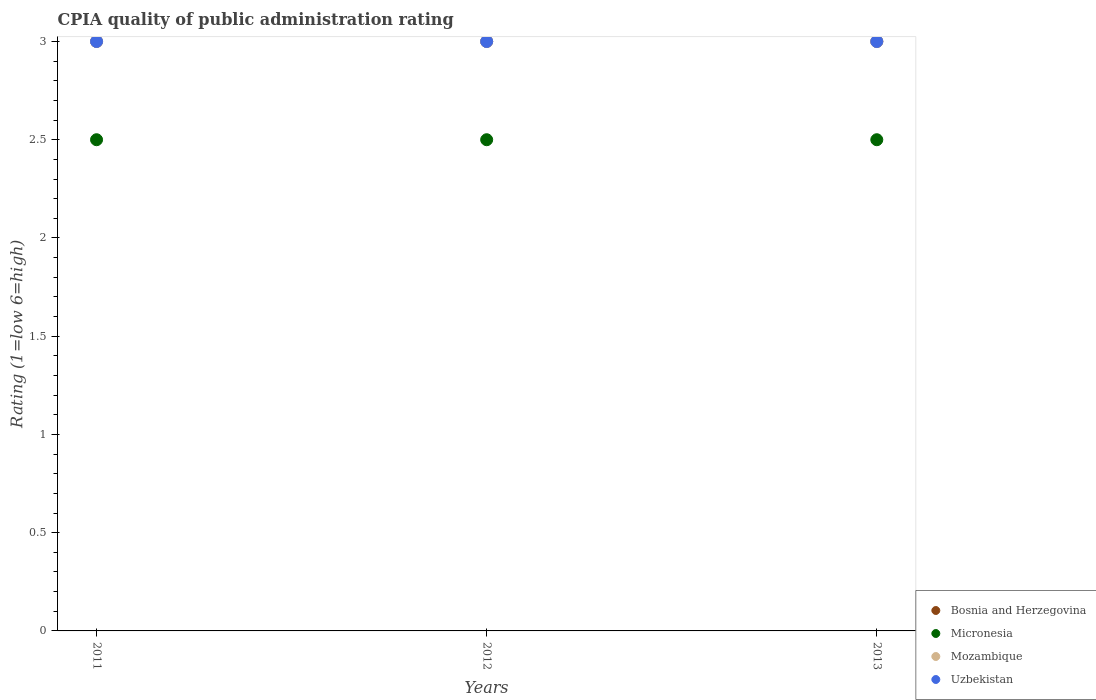How many different coloured dotlines are there?
Your answer should be compact. 4. What is the CPIA rating in Uzbekistan in 2013?
Offer a very short reply. 3. Across all years, what is the minimum CPIA rating in Bosnia and Herzegovina?
Ensure brevity in your answer.  3. In which year was the CPIA rating in Mozambique minimum?
Offer a very short reply. 2011. What is the total CPIA rating in Micronesia in the graph?
Provide a succinct answer. 7.5. What is the difference between the CPIA rating in Uzbekistan in 2012 and that in 2013?
Make the answer very short. 0. What is the ratio of the CPIA rating in Uzbekistan in 2011 to that in 2013?
Provide a short and direct response. 1. Is the CPIA rating in Micronesia in 2011 less than that in 2013?
Make the answer very short. No. Is the difference between the CPIA rating in Bosnia and Herzegovina in 2011 and 2012 greater than the difference between the CPIA rating in Uzbekistan in 2011 and 2012?
Your answer should be very brief. No. What is the difference between the highest and the lowest CPIA rating in Mozambique?
Offer a terse response. 0. In how many years, is the CPIA rating in Uzbekistan greater than the average CPIA rating in Uzbekistan taken over all years?
Make the answer very short. 0. Is it the case that in every year, the sum of the CPIA rating in Mozambique and CPIA rating in Uzbekistan  is greater than the sum of CPIA rating in Micronesia and CPIA rating in Bosnia and Herzegovina?
Your response must be concise. No. Is it the case that in every year, the sum of the CPIA rating in Micronesia and CPIA rating in Bosnia and Herzegovina  is greater than the CPIA rating in Mozambique?
Offer a very short reply. Yes. Are the values on the major ticks of Y-axis written in scientific E-notation?
Your answer should be very brief. No. Where does the legend appear in the graph?
Offer a very short reply. Bottom right. What is the title of the graph?
Your answer should be compact. CPIA quality of public administration rating. Does "Ukraine" appear as one of the legend labels in the graph?
Ensure brevity in your answer.  No. What is the label or title of the Y-axis?
Offer a terse response. Rating (1=low 6=high). What is the Rating (1=low 6=high) of Micronesia in 2011?
Your response must be concise. 2.5. What is the Rating (1=low 6=high) in Bosnia and Herzegovina in 2012?
Make the answer very short. 3. What is the Rating (1=low 6=high) of Micronesia in 2012?
Provide a short and direct response. 2.5. What is the Rating (1=low 6=high) in Uzbekistan in 2012?
Provide a succinct answer. 3. What is the Rating (1=low 6=high) of Micronesia in 2013?
Your answer should be very brief. 2.5. What is the Rating (1=low 6=high) in Uzbekistan in 2013?
Provide a short and direct response. 3. Across all years, what is the maximum Rating (1=low 6=high) in Bosnia and Herzegovina?
Offer a terse response. 3. Across all years, what is the maximum Rating (1=low 6=high) of Micronesia?
Offer a terse response. 2.5. Across all years, what is the maximum Rating (1=low 6=high) of Uzbekistan?
Your response must be concise. 3. Across all years, what is the minimum Rating (1=low 6=high) in Bosnia and Herzegovina?
Your response must be concise. 3. Across all years, what is the minimum Rating (1=low 6=high) of Mozambique?
Provide a short and direct response. 3. What is the total Rating (1=low 6=high) in Micronesia in the graph?
Provide a short and direct response. 7.5. What is the total Rating (1=low 6=high) of Uzbekistan in the graph?
Give a very brief answer. 9. What is the difference between the Rating (1=low 6=high) in Micronesia in 2011 and that in 2012?
Ensure brevity in your answer.  0. What is the difference between the Rating (1=low 6=high) in Mozambique in 2011 and that in 2013?
Offer a terse response. 0. What is the difference between the Rating (1=low 6=high) in Bosnia and Herzegovina in 2012 and that in 2013?
Your answer should be compact. 0. What is the difference between the Rating (1=low 6=high) of Micronesia in 2012 and that in 2013?
Ensure brevity in your answer.  0. What is the difference between the Rating (1=low 6=high) in Bosnia and Herzegovina in 2011 and the Rating (1=low 6=high) in Mozambique in 2012?
Offer a very short reply. 0. What is the difference between the Rating (1=low 6=high) of Micronesia in 2011 and the Rating (1=low 6=high) of Mozambique in 2012?
Keep it short and to the point. -0.5. What is the difference between the Rating (1=low 6=high) in Micronesia in 2011 and the Rating (1=low 6=high) in Uzbekistan in 2012?
Provide a succinct answer. -0.5. What is the difference between the Rating (1=low 6=high) in Micronesia in 2011 and the Rating (1=low 6=high) in Uzbekistan in 2013?
Your answer should be compact. -0.5. What is the difference between the Rating (1=low 6=high) of Mozambique in 2011 and the Rating (1=low 6=high) of Uzbekistan in 2013?
Your answer should be very brief. 0. What is the difference between the Rating (1=low 6=high) of Bosnia and Herzegovina in 2012 and the Rating (1=low 6=high) of Uzbekistan in 2013?
Offer a very short reply. 0. What is the difference between the Rating (1=low 6=high) of Micronesia in 2012 and the Rating (1=low 6=high) of Mozambique in 2013?
Make the answer very short. -0.5. What is the average Rating (1=low 6=high) in Mozambique per year?
Your answer should be compact. 3. In the year 2011, what is the difference between the Rating (1=low 6=high) in Bosnia and Herzegovina and Rating (1=low 6=high) in Micronesia?
Your response must be concise. 0.5. In the year 2011, what is the difference between the Rating (1=low 6=high) of Bosnia and Herzegovina and Rating (1=low 6=high) of Mozambique?
Provide a short and direct response. 0. In the year 2011, what is the difference between the Rating (1=low 6=high) in Micronesia and Rating (1=low 6=high) in Mozambique?
Offer a terse response. -0.5. In the year 2011, what is the difference between the Rating (1=low 6=high) of Micronesia and Rating (1=low 6=high) of Uzbekistan?
Give a very brief answer. -0.5. In the year 2011, what is the difference between the Rating (1=low 6=high) in Mozambique and Rating (1=low 6=high) in Uzbekistan?
Your response must be concise. 0. In the year 2012, what is the difference between the Rating (1=low 6=high) in Bosnia and Herzegovina and Rating (1=low 6=high) in Micronesia?
Make the answer very short. 0.5. In the year 2012, what is the difference between the Rating (1=low 6=high) of Bosnia and Herzegovina and Rating (1=low 6=high) of Mozambique?
Your answer should be compact. 0. In the year 2012, what is the difference between the Rating (1=low 6=high) of Bosnia and Herzegovina and Rating (1=low 6=high) of Uzbekistan?
Your answer should be compact. 0. In the year 2012, what is the difference between the Rating (1=low 6=high) in Micronesia and Rating (1=low 6=high) in Mozambique?
Provide a succinct answer. -0.5. In the year 2012, what is the difference between the Rating (1=low 6=high) in Mozambique and Rating (1=low 6=high) in Uzbekistan?
Your response must be concise. 0. In the year 2013, what is the difference between the Rating (1=low 6=high) in Bosnia and Herzegovina and Rating (1=low 6=high) in Micronesia?
Ensure brevity in your answer.  0.5. What is the ratio of the Rating (1=low 6=high) of Bosnia and Herzegovina in 2011 to that in 2012?
Your answer should be compact. 1. What is the ratio of the Rating (1=low 6=high) in Micronesia in 2011 to that in 2013?
Offer a very short reply. 1. What is the ratio of the Rating (1=low 6=high) in Mozambique in 2012 to that in 2013?
Make the answer very short. 1. What is the difference between the highest and the second highest Rating (1=low 6=high) in Mozambique?
Provide a succinct answer. 0. What is the difference between the highest and the second highest Rating (1=low 6=high) in Uzbekistan?
Make the answer very short. 0. What is the difference between the highest and the lowest Rating (1=low 6=high) of Bosnia and Herzegovina?
Make the answer very short. 0. 